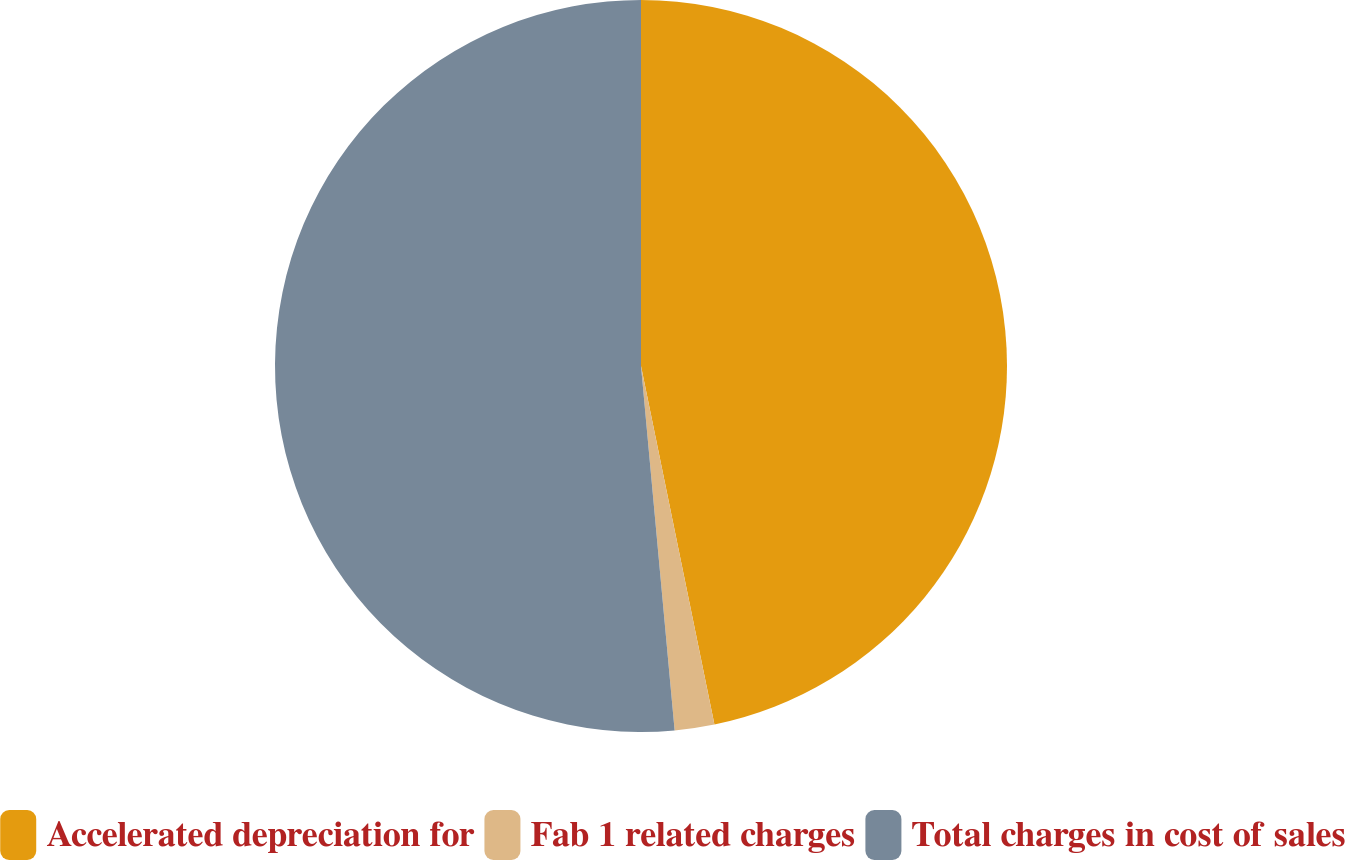Convert chart. <chart><loc_0><loc_0><loc_500><loc_500><pie_chart><fcel>Accelerated depreciation for<fcel>Fab 1 related charges<fcel>Total charges in cost of sales<nl><fcel>46.78%<fcel>1.75%<fcel>51.46%<nl></chart> 